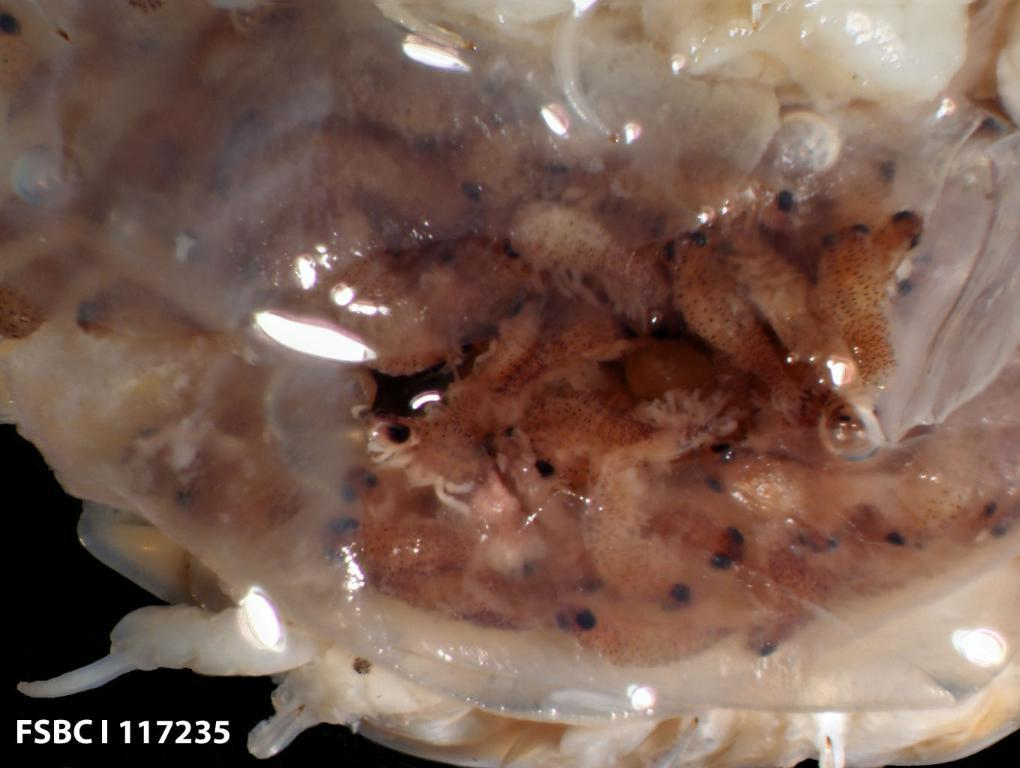What type of animals can be seen in the image? Fishes can be seen in the image. Can you describe the environment in which the fishes are located? The image does not provide enough information to determine the environment of the fishes. What might the fishes be doing in the image? The image does not provide enough information to determine the activity of the fishes. What type of scarf is the fish wearing in the image? There is no scarf present in the image, as fishes do not wear clothing. 